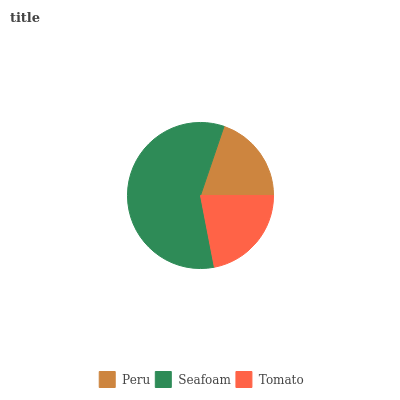Is Peru the minimum?
Answer yes or no. Yes. Is Seafoam the maximum?
Answer yes or no. Yes. Is Tomato the minimum?
Answer yes or no. No. Is Tomato the maximum?
Answer yes or no. No. Is Seafoam greater than Tomato?
Answer yes or no. Yes. Is Tomato less than Seafoam?
Answer yes or no. Yes. Is Tomato greater than Seafoam?
Answer yes or no. No. Is Seafoam less than Tomato?
Answer yes or no. No. Is Tomato the high median?
Answer yes or no. Yes. Is Tomato the low median?
Answer yes or no. Yes. Is Seafoam the high median?
Answer yes or no. No. Is Peru the low median?
Answer yes or no. No. 